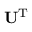Convert formula to latex. <formula><loc_0><loc_0><loc_500><loc_500>U ^ { T }</formula> 